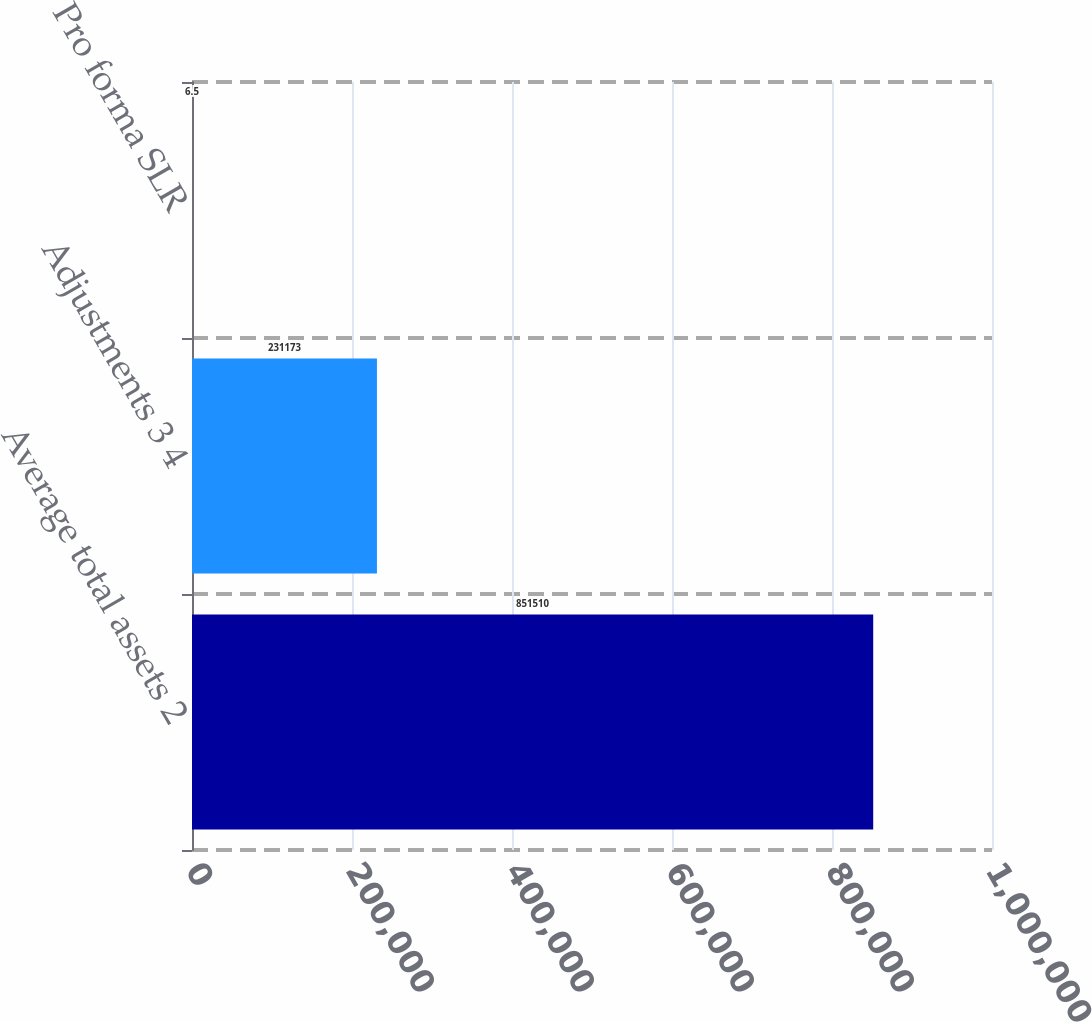Convert chart to OTSL. <chart><loc_0><loc_0><loc_500><loc_500><bar_chart><fcel>Average total assets 2<fcel>Adjustments 3 4<fcel>Pro forma SLR<nl><fcel>851510<fcel>231173<fcel>6.5<nl></chart> 